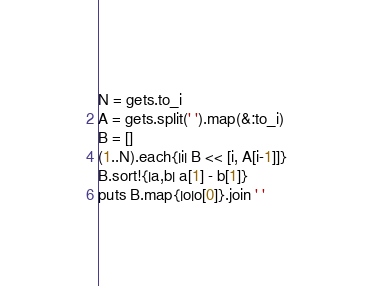Convert code to text. <code><loc_0><loc_0><loc_500><loc_500><_Ruby_>N = gets.to_i
A = gets.split(' ').map(&:to_i)
B = []
(1..N).each{|i| B << [i, A[i-1]]}
B.sort!{|a,b| a[1] - b[1]}
puts B.map{|o|o[0]}.join ' '

</code> 